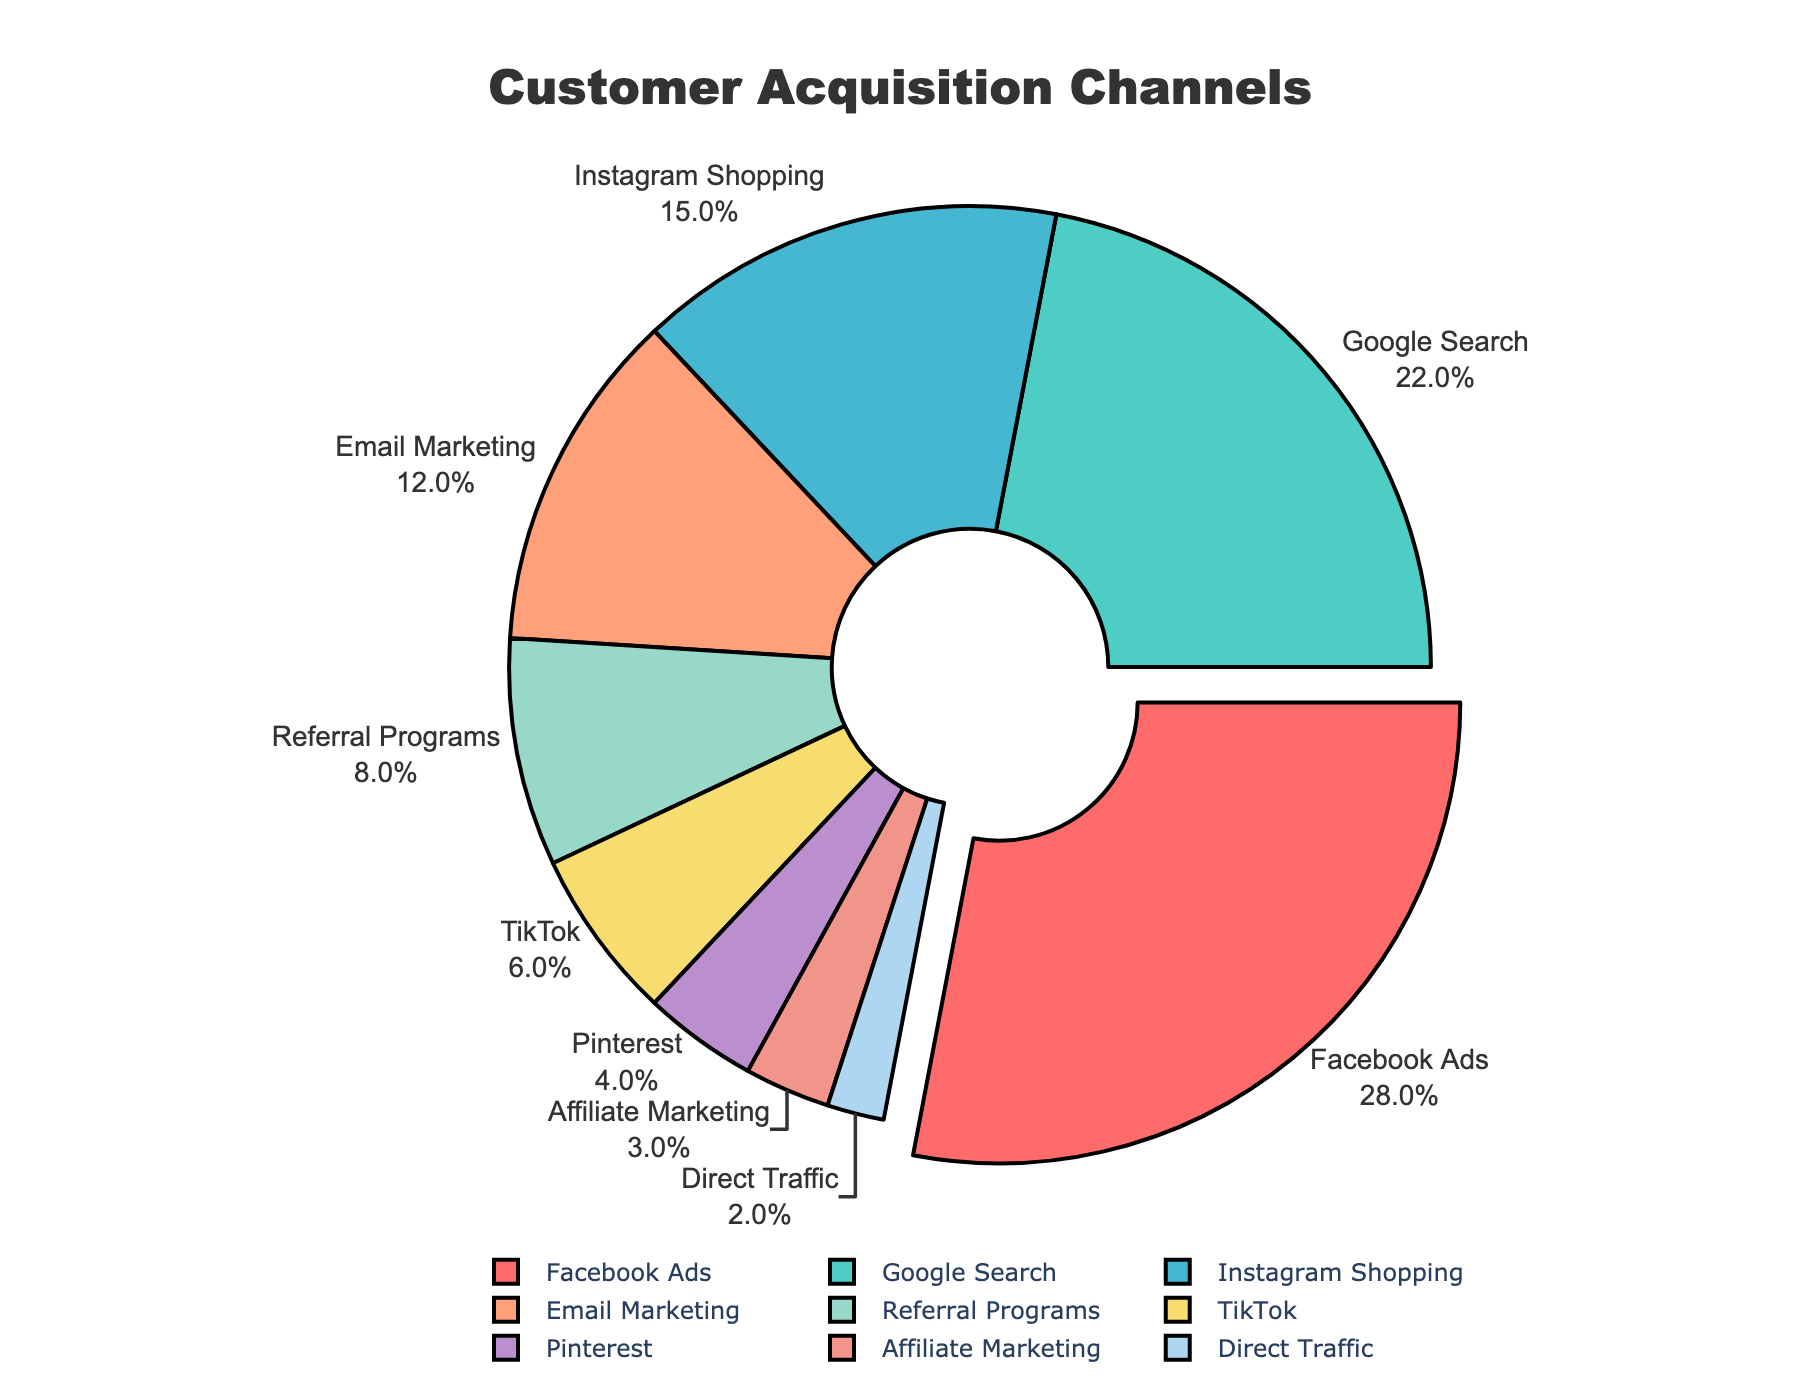What is the percentage of customers acquired through Facebook Ads and Google Search combined? To find the combined percentage, simply add the two individual percentages: 28% (Facebook Ads) + 22% (Google Search) = 50%.
Answer: 50% Which acquisition channel has the least percentage of customers? Look for the segment with the smallest percentage value, which in this case is Direct Traffic with 2%.
Answer: Direct Traffic How does the percentage of customers acquired through Instagram Shopping compare to that of Email Marketing? Instagram Shopping has 15%, and Email Marketing has 12%. Comparing the two, Instagram Shopping (15%) has a higher percentage than Email Marketing (12%) by 3%.
Answer: Instagram Shopping has 3% more Which acquisition channel is highlighted or pulled out from the pie chart? The segment that is pulled out is the one with the highest percentage, which is Facebook Ads with 28%.
Answer: Facebook Ads What is the average percentage of customers acquired through Referral Programs, TikTok, and Pinterest? Sum the percentages and divide by the number of channels: (Referral Programs 8% + TikTok 6% + Pinterest 4%) / 3 = 18% / 3 = 6%.
Answer: 6% Is the percentage of customers acquired through Google Search greater than the combined percentage of Affiliate Marketing and Direct Traffic? Google Search has 22%. Combined percentage of Affiliate Marketing (3%) and Direct Traffic (2%) is 3% + 2% = 5%. Since 22% is greater than 5%, the answer is yes.
Answer: Yes What do the red, green, and yellow segments on the pie chart correspond to? The red segment represents Facebook Ads, the green represents Google Search, and the yellow represents TikTok.
Answer: Facebook Ads, Google Search, TikTok 